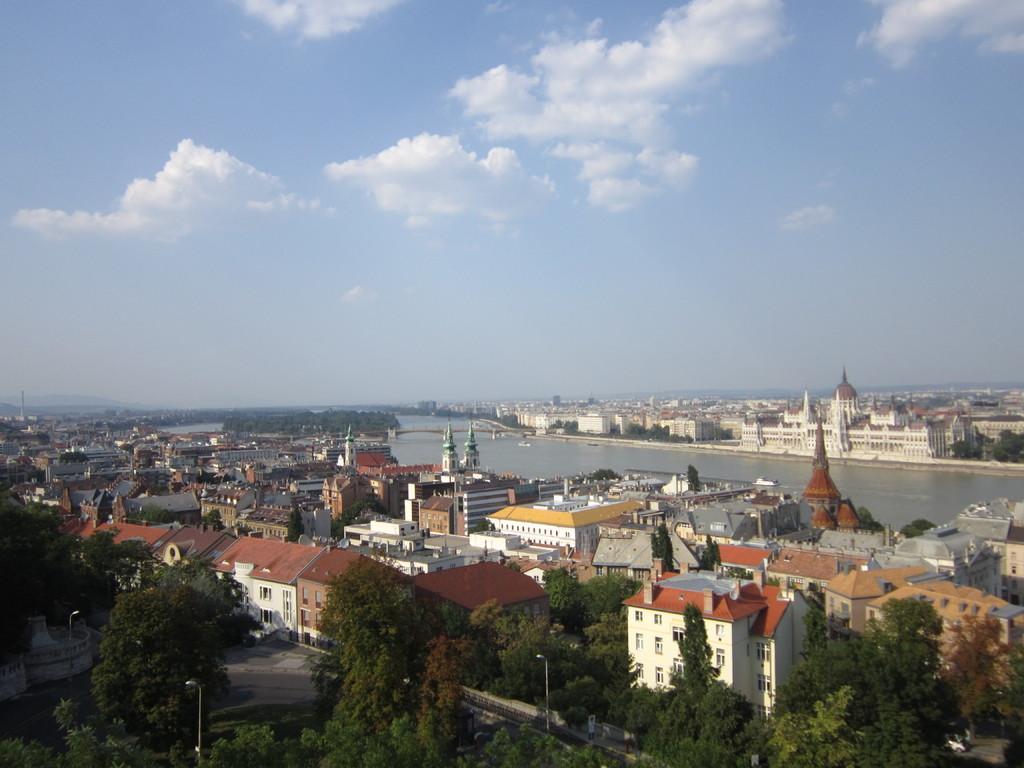Please provide a concise description of this image. This is a picture of the city where there are poles, lights, roads, buildings, water, bridge, trees,sky. 